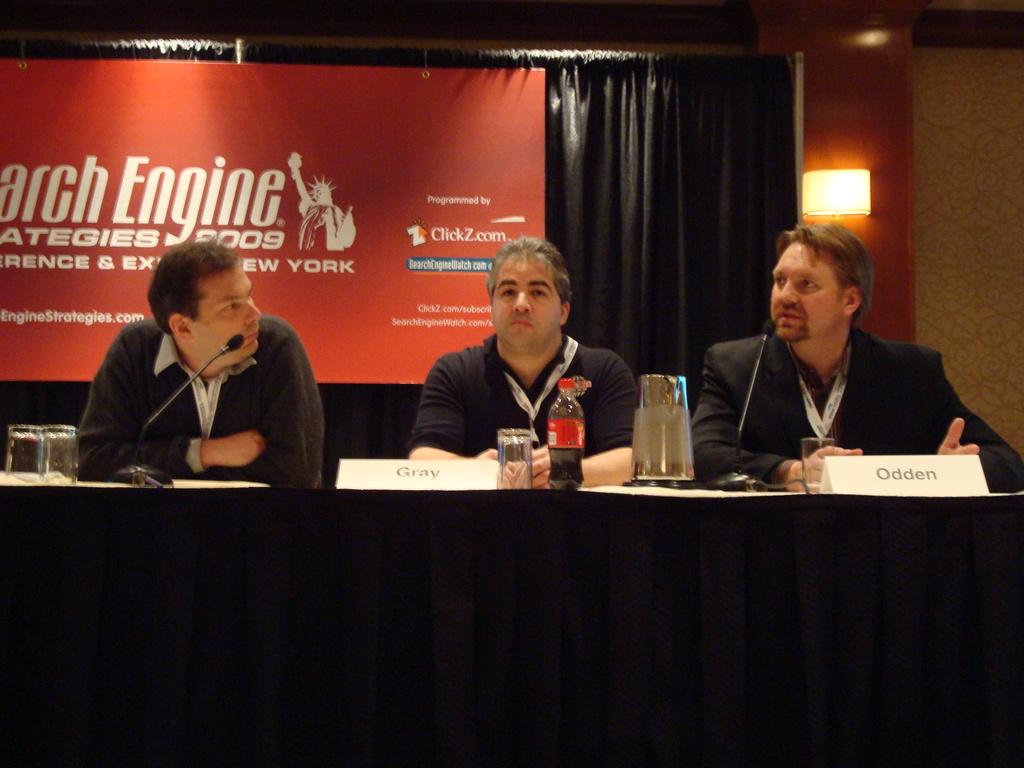What is the last word of the first line?
Offer a very short reply. Engine. What is the man on the rights last name?
Your answer should be very brief. Odden. 